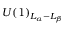Convert formula to latex. <formula><loc_0><loc_0><loc_500><loc_500>U ( 1 ) _ { L _ { \alpha } - L _ { \beta } }</formula> 